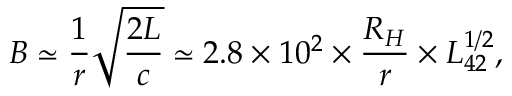Convert formula to latex. <formula><loc_0><loc_0><loc_500><loc_500>B \simeq \frac { 1 } { r } \sqrt { \frac { 2 L } { c } } \simeq 2 . 8 \times 1 0 ^ { 2 } \times \frac { R _ { H } } { r } \times L _ { 4 2 } ^ { 1 / 2 } ,</formula> 